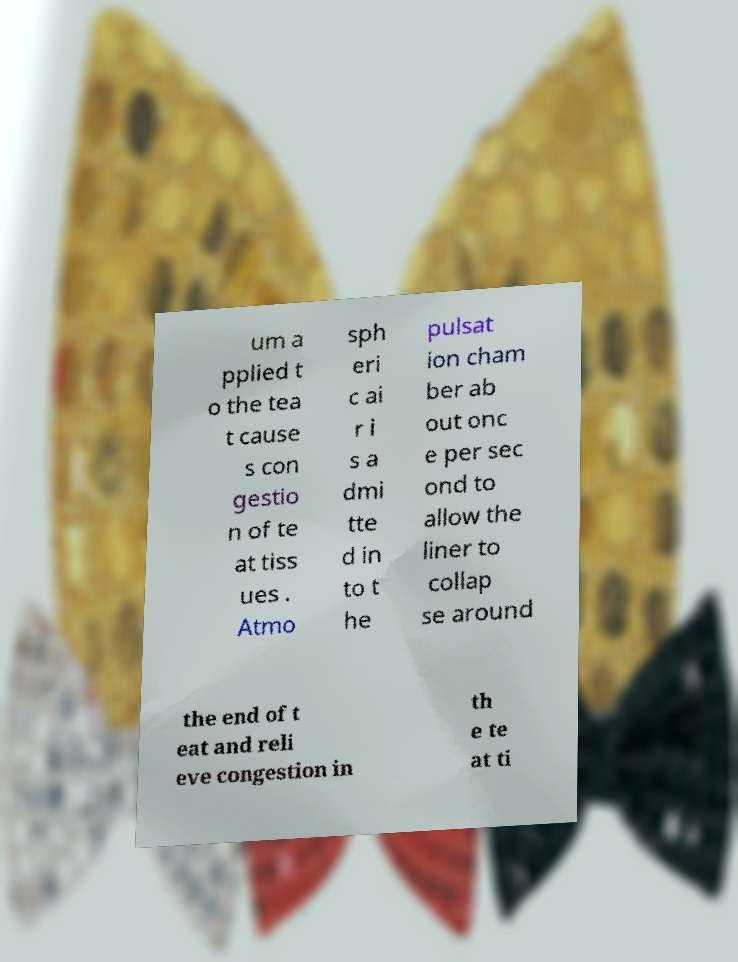For documentation purposes, I need the text within this image transcribed. Could you provide that? um a pplied t o the tea t cause s con gestio n of te at tiss ues . Atmo sph eri c ai r i s a dmi tte d in to t he pulsat ion cham ber ab out onc e per sec ond to allow the liner to collap se around the end of t eat and reli eve congestion in th e te at ti 